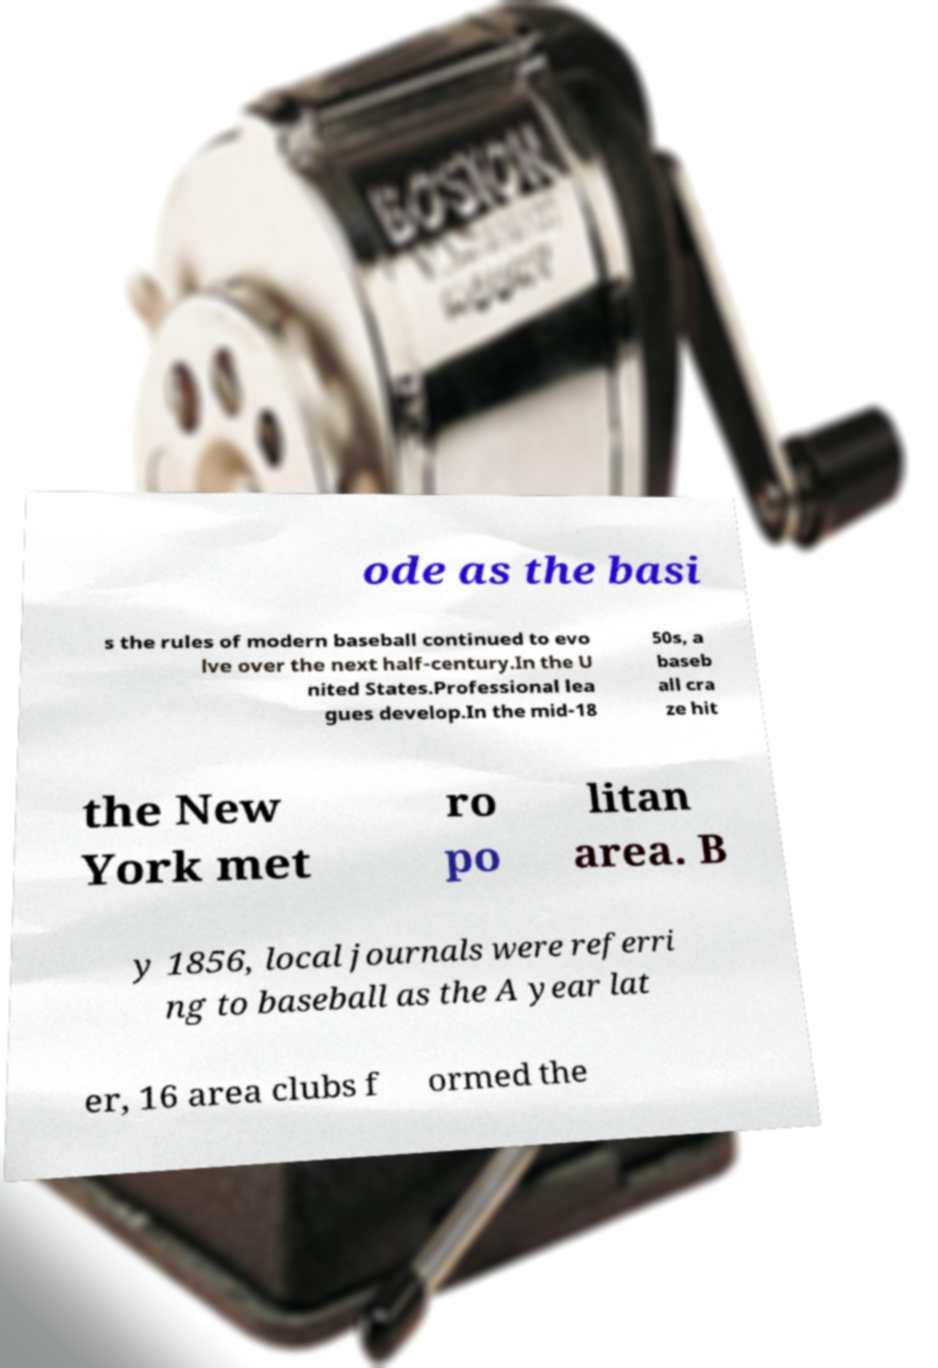What messages or text are displayed in this image? I need them in a readable, typed format. ode as the basi s the rules of modern baseball continued to evo lve over the next half-century.In the U nited States.Professional lea gues develop.In the mid-18 50s, a baseb all cra ze hit the New York met ro po litan area. B y 1856, local journals were referri ng to baseball as the A year lat er, 16 area clubs f ormed the 